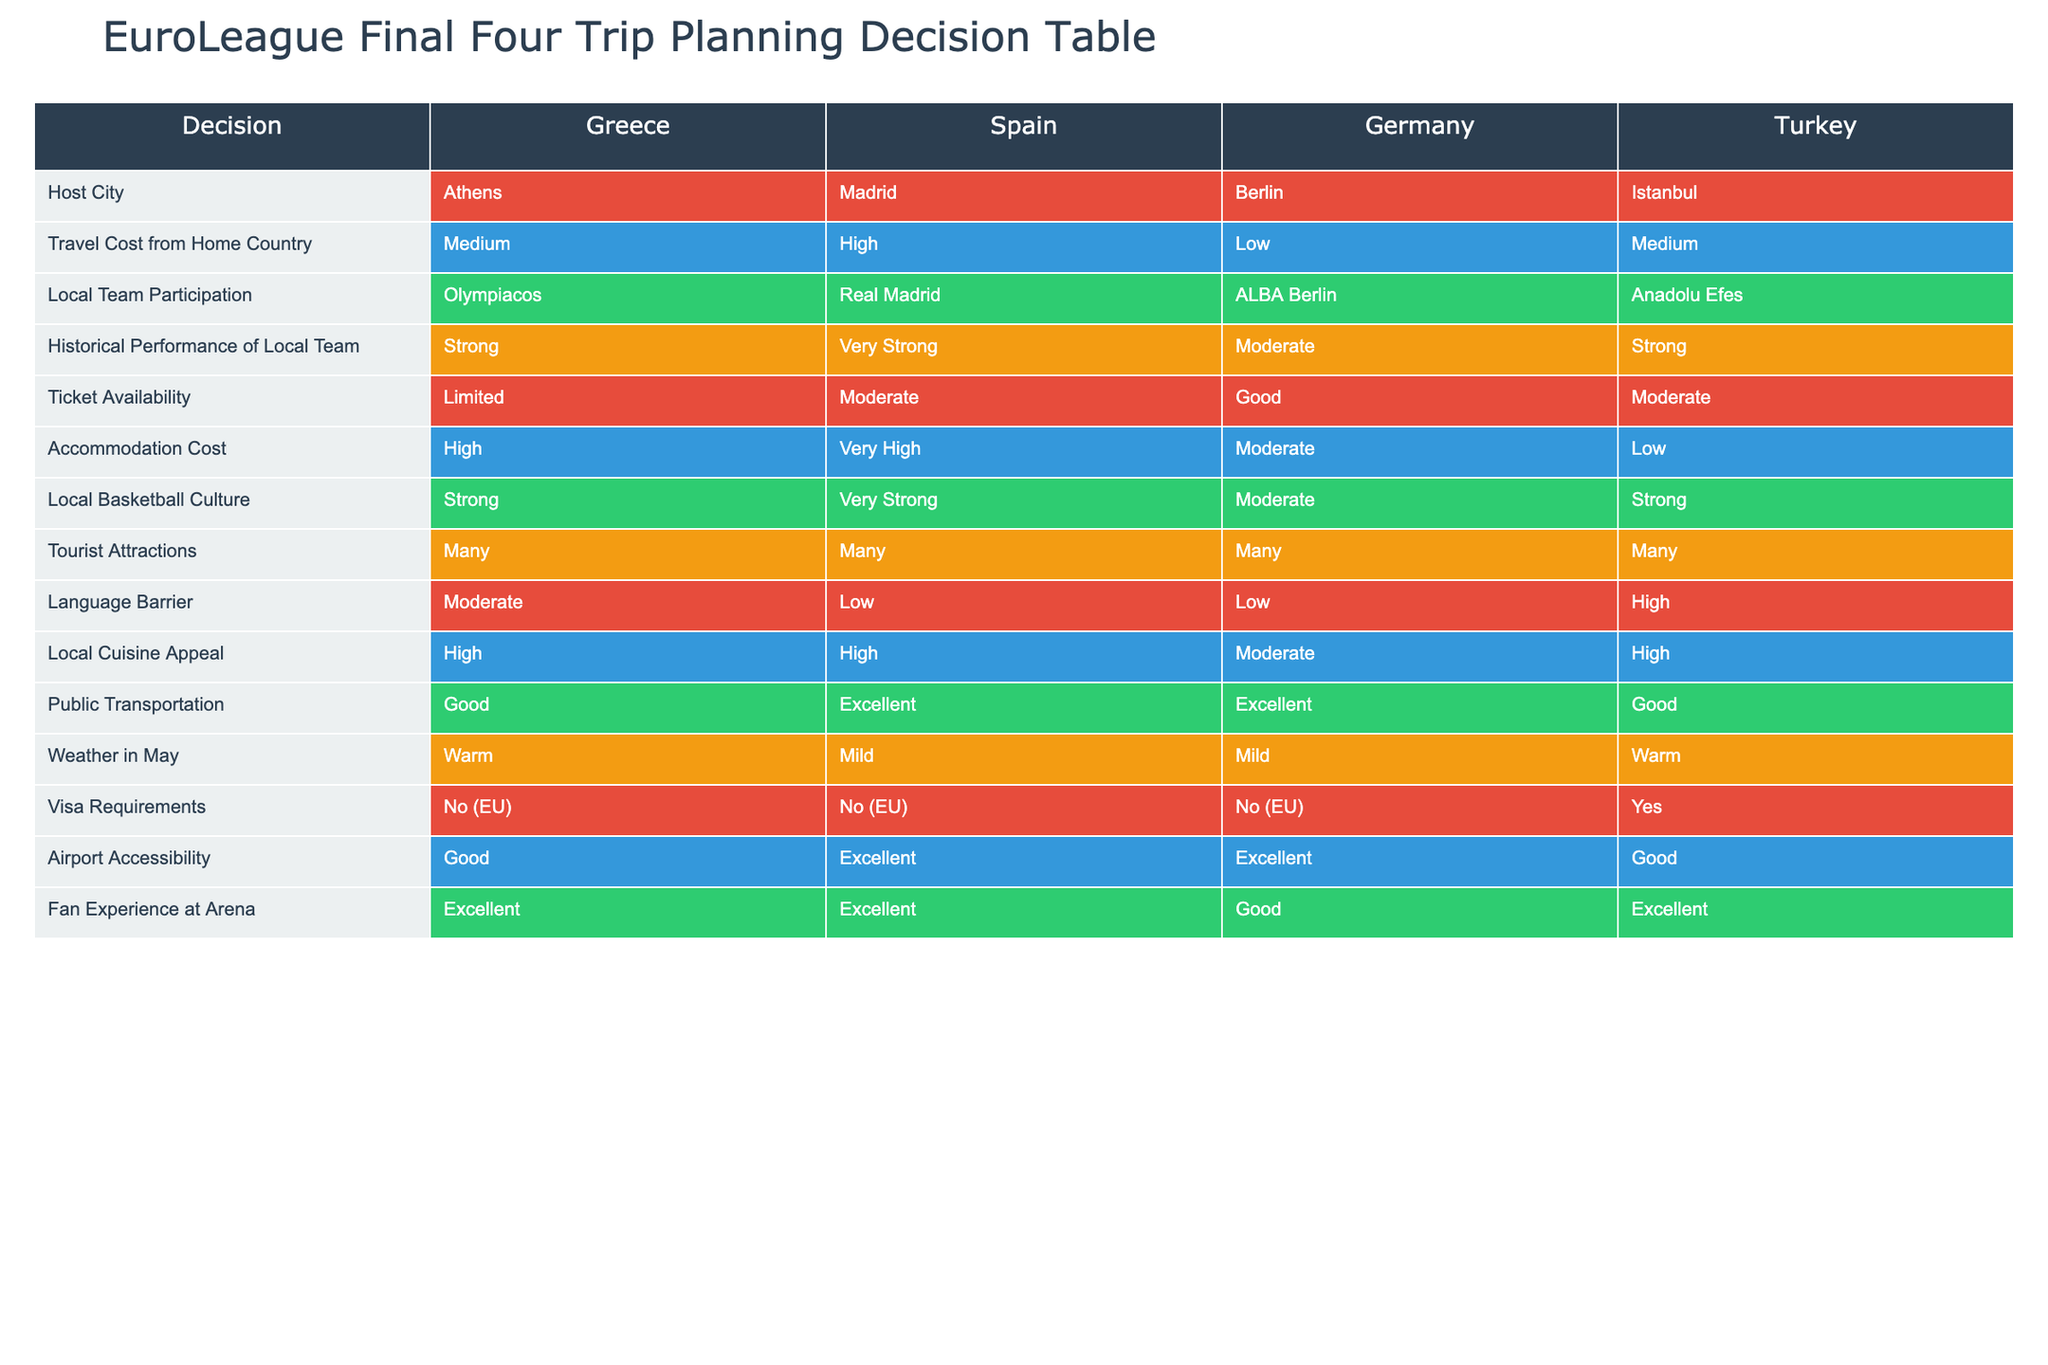What is the local team participating in the EuroLeague Final Four if it is hosted in Athens? Referring to the table, under the "Local Team Participation" column for Greece (Athens), the team listed is Olympiacos.
Answer: Olympiacos Which host city has the highest accommodation cost? Comparing the "Accommodation Cost" column across all host cities, Spain (Madrid) shows the highest accommodation cost categorized as Very High.
Answer: Madrid Is there a language barrier in Istanbul? Looking at the "Language Barrier" column for Turkey (Istanbul), it is categorized as High, indicating a significant language barrier.
Answer: Yes Which location has both the best ticket availability and the highest local basketball culture? Examining the "Ticket Availability" (Good) and "Local Basketball Culture" (Very Strong) columns, Germany (Berlin) has good ticket availability and a moderate basketball culture. The only city that has both excellent ticket availability and strong basketball culture is Athens (for culture) but it is limited on tickets.
Answer: None What is the difference in local cuisine appeal between Berlin and Athens? For local cuisine appeal, Berlin is categorized as Moderate, while Athens is categorized as High. The difference in appeal is High - Moderate, which is one level higher.
Answer: 1 level Which host city offers the best public transportation? Looking at the "Public Transportation" column, Spain (Madrid) and Germany (Berlin) both have an Excellent rating, making them the best options for public transportation.
Answer: Madrid and Berlin How many host cities require a visa for travel? Checking the "Visa Requirements" column, only Turkey (Istanbul) has a Yes entry, indicating it is the only city requiring a visa to travel.
Answer: One What is the weather like in the host city of Madrid in May? The "Weather in May" column lists Madrid as Mild, indicating comfortable weather conditions for visiting in May.
Answer: Mild If you want to experience a strong local basketball culture, which host city should you consider? Referring to the "Local Basketball Culture" column, both Greece (Athens) and Turkey (Istanbul) are rated as Strong. However, since Athens edges on local team performance it might be a better option overall.
Answer: Athens or Istanbul 